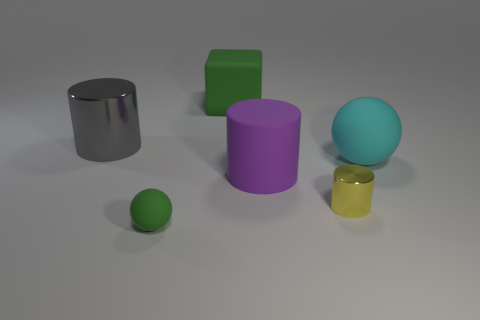Are there any matte spheres that have the same size as the purple matte thing?
Offer a terse response. Yes. How many cyan things are small matte cylinders or matte objects?
Provide a short and direct response. 1. What number of tiny metal cylinders are the same color as the big ball?
Your answer should be compact. 0. Are there any other things that are the same shape as the small yellow shiny thing?
Give a very brief answer. Yes. What number of cylinders are large yellow things or gray objects?
Make the answer very short. 1. There is a matte object that is on the right side of the big purple thing; what is its color?
Give a very brief answer. Cyan. There is a cyan object that is the same size as the purple matte thing; what shape is it?
Offer a very short reply. Sphere. How many matte objects are in front of the big cyan thing?
Give a very brief answer. 2. How many objects are small yellow metallic things or tiny green metallic blocks?
Provide a short and direct response. 1. There is a object that is behind the tiny yellow object and right of the purple rubber thing; what shape is it?
Offer a terse response. Sphere. 